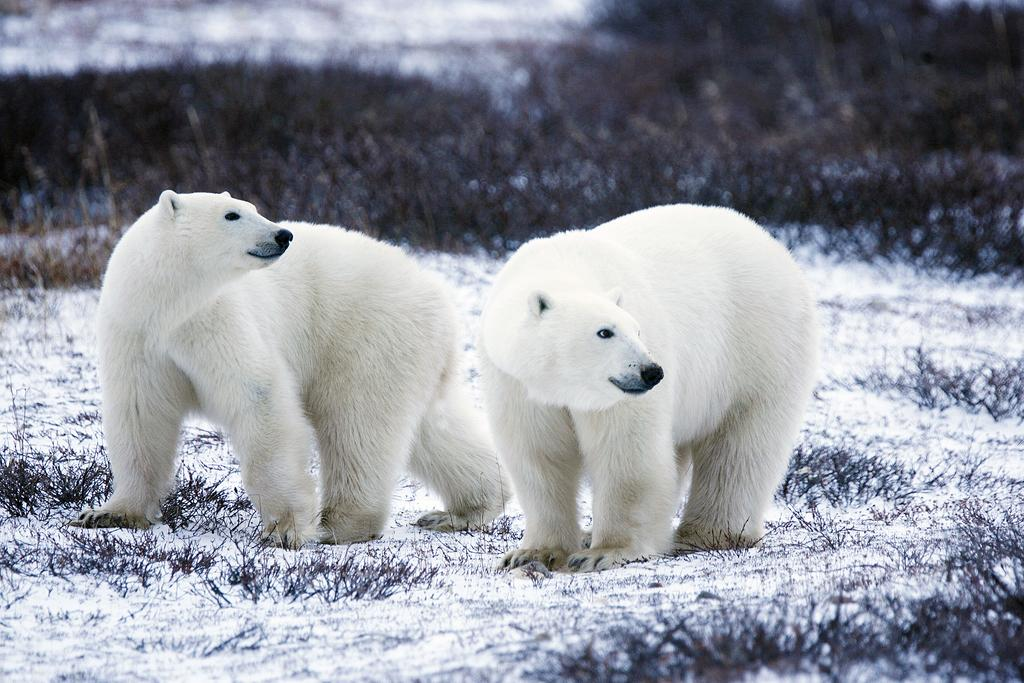What animals are in the center of the image? There are polar bears in the center of the image. What type of terrain is visible at the bottom of the image? There is snow at the bottom of the image. What type of vegetation can be seen in the background of the image? There is grass visible in the background of the image. How many servants are attending to the polar bears in the image? There are no servants present in the image; it features polar bears in a snowy environment. What type of berry can be seen growing on the grass in the background? There are no berries visible in the image; it only shows grass in the background. 